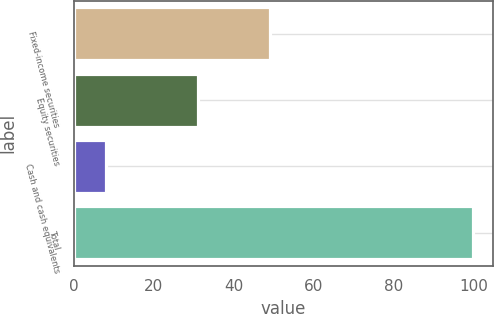Convert chart. <chart><loc_0><loc_0><loc_500><loc_500><bar_chart><fcel>Fixed-income securities<fcel>Equity securities<fcel>Cash and cash equivalents<fcel>Total<nl><fcel>49<fcel>31<fcel>8<fcel>100<nl></chart> 